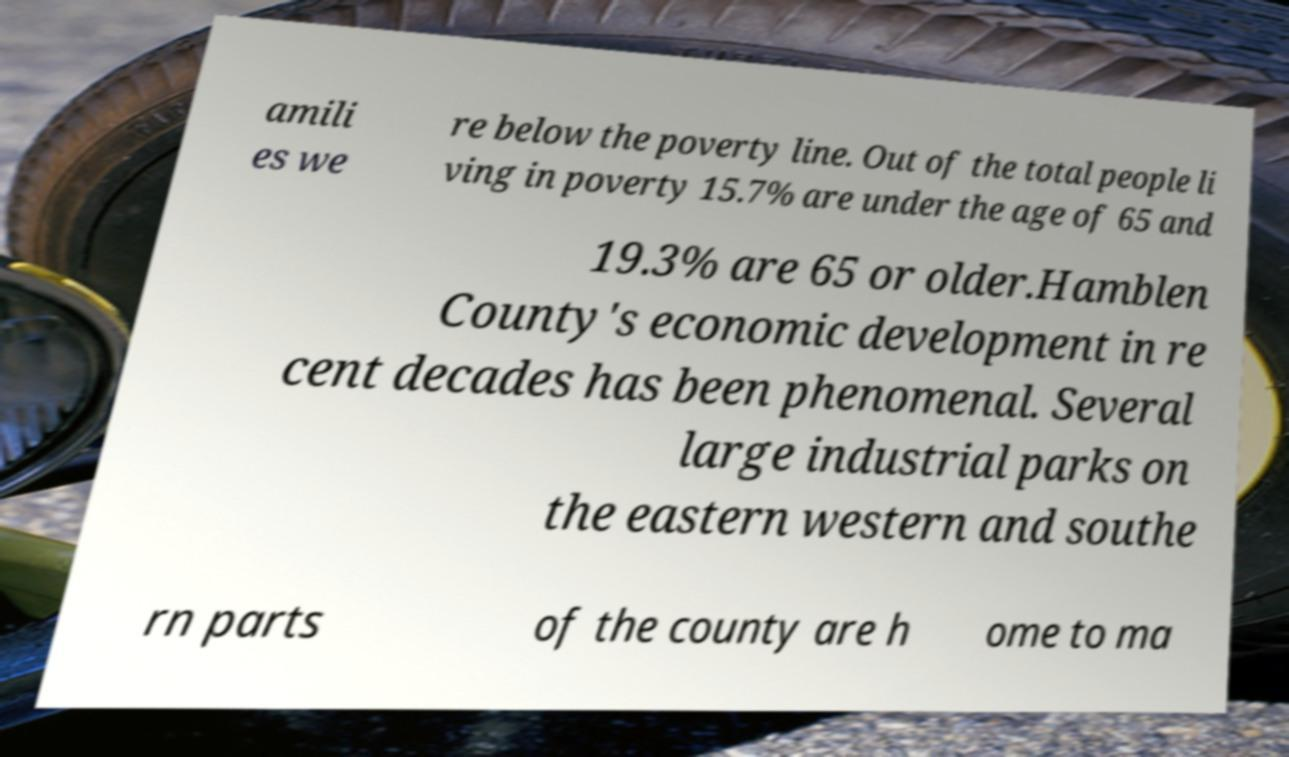Please read and relay the text visible in this image. What does it say? amili es we re below the poverty line. Out of the total people li ving in poverty 15.7% are under the age of 65 and 19.3% are 65 or older.Hamblen County's economic development in re cent decades has been phenomenal. Several large industrial parks on the eastern western and southe rn parts of the county are h ome to ma 